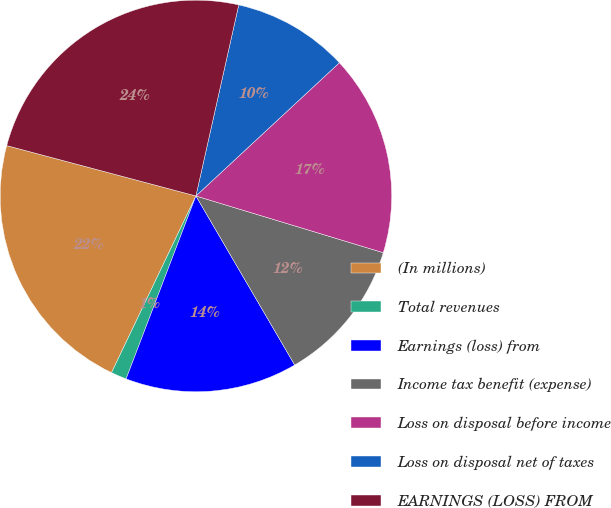<chart> <loc_0><loc_0><loc_500><loc_500><pie_chart><fcel>(In millions)<fcel>Total revenues<fcel>Earnings (loss) from<fcel>Income tax benefit (expense)<fcel>Loss on disposal before income<fcel>Loss on disposal net of taxes<fcel>EARNINGS (LOSS) FROM<nl><fcel>22.05%<fcel>1.29%<fcel>14.22%<fcel>11.9%<fcel>16.59%<fcel>9.58%<fcel>24.37%<nl></chart> 